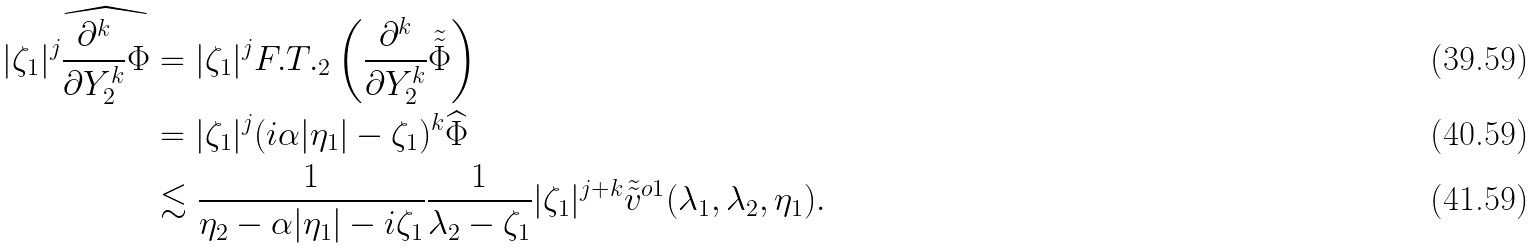Convert formula to latex. <formula><loc_0><loc_0><loc_500><loc_500>| \zeta _ { 1 } | ^ { j } \widehat { \frac { \partial ^ { k } } { \partial Y _ { 2 } ^ { k } } \Phi } & = | \zeta _ { 1 } | ^ { j } F . T . _ { 2 } \left ( \frac { \partial ^ { k } } { \partial Y _ { 2 } ^ { k } } \tilde { \tilde { \Phi } } \right ) \\ & = | \zeta _ { 1 } | ^ { j } ( i \alpha | \eta _ { 1 } | - \zeta _ { 1 } ) ^ { k } \widehat { \Phi } \\ & \lesssim \frac { 1 } { \eta _ { 2 } - \alpha | \eta _ { 1 } | - i \zeta _ { 1 } } \frac { 1 } { \lambda _ { 2 } - \zeta _ { 1 } } | \zeta _ { 1 } | ^ { j + k } \tilde { \tilde { v } } ^ { o 1 } ( \lambda _ { 1 } , \lambda _ { 2 } , \eta _ { 1 } ) .</formula> 